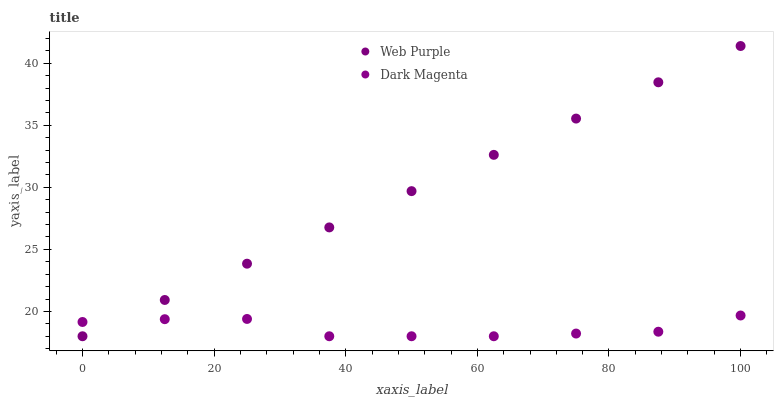Does Dark Magenta have the minimum area under the curve?
Answer yes or no. Yes. Does Web Purple have the maximum area under the curve?
Answer yes or no. Yes. Does Dark Magenta have the maximum area under the curve?
Answer yes or no. No. Is Web Purple the smoothest?
Answer yes or no. Yes. Is Dark Magenta the roughest?
Answer yes or no. Yes. Is Dark Magenta the smoothest?
Answer yes or no. No. Does Web Purple have the lowest value?
Answer yes or no. Yes. Does Web Purple have the highest value?
Answer yes or no. Yes. Does Dark Magenta have the highest value?
Answer yes or no. No. Does Dark Magenta intersect Web Purple?
Answer yes or no. Yes. Is Dark Magenta less than Web Purple?
Answer yes or no. No. Is Dark Magenta greater than Web Purple?
Answer yes or no. No. 